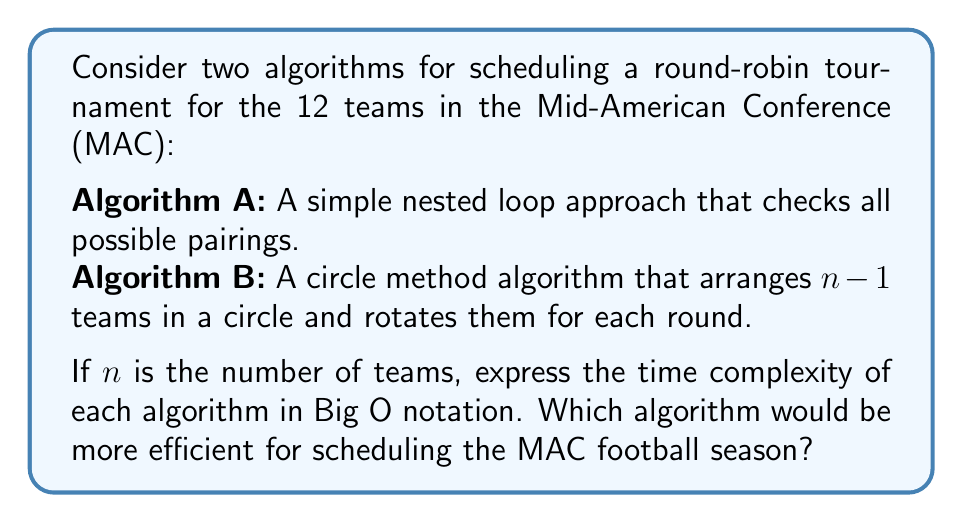Show me your answer to this math problem. Let's analyze the time complexity of both algorithms:

1. Algorithm A (Nested Loop Approach):
   This algorithm considers all possible pairings of teams. For n teams:
   - The outer loop runs n-1 times (for n-1 rounds)
   - For each round, it checks n/2 pairings
   - For each pairing, it needs to check if the teams have already played (worst case: O(n) operations)

   Therefore, the time complexity is:
   $$O((n-1) \cdot \frac{n}{2} \cdot n) = O(n^3)$$

2. Algorithm B (Circle Method):
   This algorithm arranges n-1 teams in a circle and rotates them for each round:
   - It performs n-1 rotations (for n-1 rounds)
   - For each rotation, it makes n/2 pairings
   - Each pairing is a constant time operation

   Therefore, the time complexity is:
   $$O((n-1) \cdot \frac{n}{2}) = O(n^2)$$

For the MAC with 12 teams:
- Algorithm A would have a complexity of O(12^3) = O(1728)
- Algorithm B would have a complexity of O(12^2) = O(144)

Algorithm B (Circle Method) is more efficient as it has a lower time complexity of O(n^2) compared to O(n^3) for Algorithm A. This means that as the number of teams increases, the performance difference between the two algorithms becomes even more significant.

For scheduling the MAC football season, Algorithm B would be the better choice, especially if we consider potential future expansions of the conference. It would provide a faster and more scalable solution for creating a fair round-robin schedule.
Answer: Algorithm B (Circle Method) with time complexity O(n^2) is more efficient for scheduling the MAC football season. 